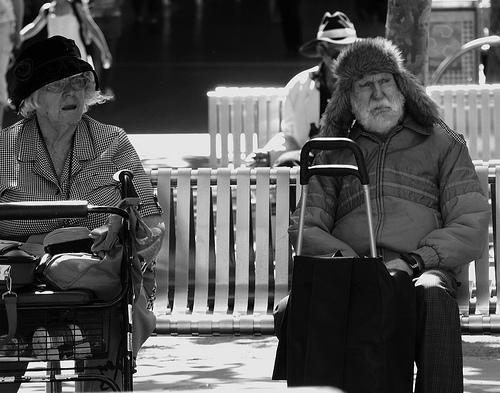How many hats are in the image?
Give a very brief answer. 3. How many people are in the photo?
Give a very brief answer. 4. 